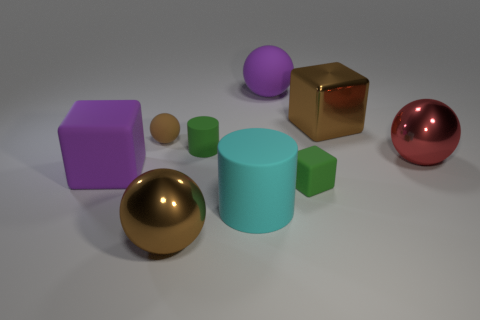Is the number of purple objects that are to the right of the cyan matte thing greater than the number of large cyan matte cylinders right of the green cube?
Your response must be concise. Yes. Do the green cube and the large purple block have the same material?
Ensure brevity in your answer.  Yes. There is a rubber cylinder in front of the purple cube; what number of green rubber things are behind it?
Make the answer very short. 2. There is a big shiny sphere to the right of the green cube; does it have the same color as the small cylinder?
Your response must be concise. No. What number of things are brown blocks or big cylinders that are in front of the tiny green cylinder?
Provide a short and direct response. 2. There is a small green rubber thing that is left of the big purple ball; does it have the same shape as the purple rubber object on the right side of the tiny rubber sphere?
Give a very brief answer. No. Is there any other thing that is the same color as the small matte cylinder?
Your answer should be very brief. Yes. The red thing that is the same material as the brown block is what shape?
Ensure brevity in your answer.  Sphere. There is a brown object that is behind the red shiny ball and left of the large cyan rubber cylinder; what material is it?
Keep it short and to the point. Rubber. Is there anything else that is the same size as the brown metallic sphere?
Keep it short and to the point. Yes. 